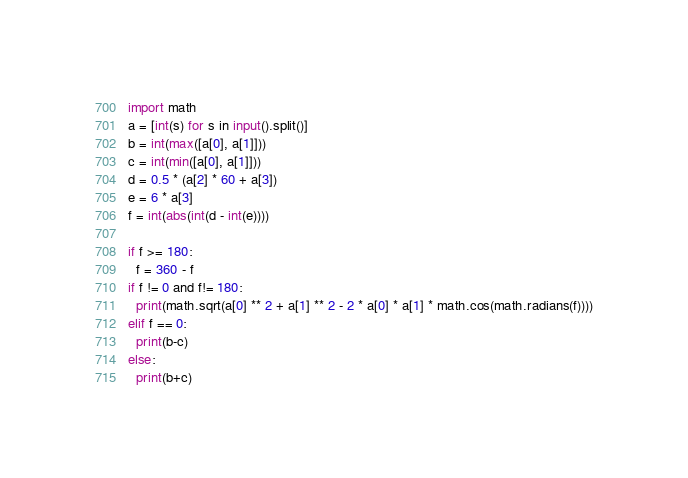Convert code to text. <code><loc_0><loc_0><loc_500><loc_500><_Python_>import math
a = [int(s) for s in input().split()]
b = int(max([a[0], a[1]]))
c = int(min([a[0], a[1]]))
d = 0.5 * (a[2] * 60 + a[3])
e = 6 * a[3]
f = int(abs(int(d - int(e))))

if f >= 180:
  f = 360 - f
if f != 0 and f!= 180:
  print(math.sqrt(a[0] ** 2 + a[1] ** 2 - 2 * a[0] * a[1] * math.cos(math.radians(f))))
elif f == 0:
  print(b-c)
else:
  print(b+c)
</code> 